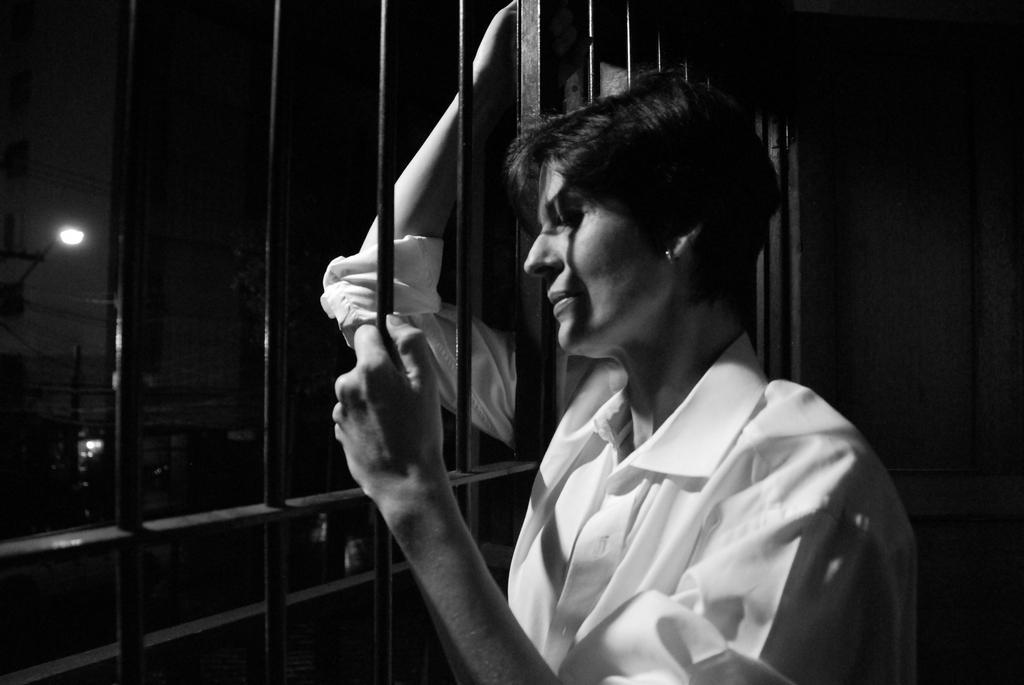Describe this image in one or two sentences. A person is standing, this is iron grill, this is street light. 